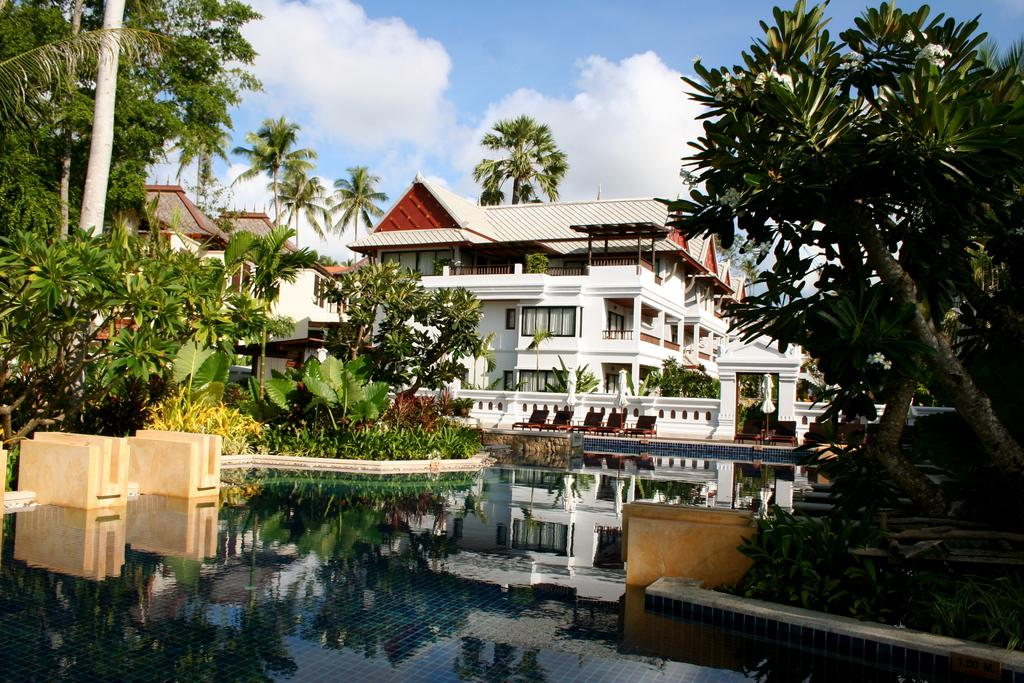What type of structures can be seen in the background of the image? There are houses in the background of the image. What other natural elements can be seen in the background of the image? There are trees in the background of the image. What is visible at the bottom of the image? There is water visible at the bottom of the image. What is visible at the top of the image? There is sky visible at the top of the image, and there are clouds visible in the sky. What is the taste of the island in the image? There is no island present in the image, so it is not possible to determine its taste. Can you describe the cow that is grazing in the water at the bottom of the image? There is no cow present in the image; it features houses, trees, water, sky, and clouds. 